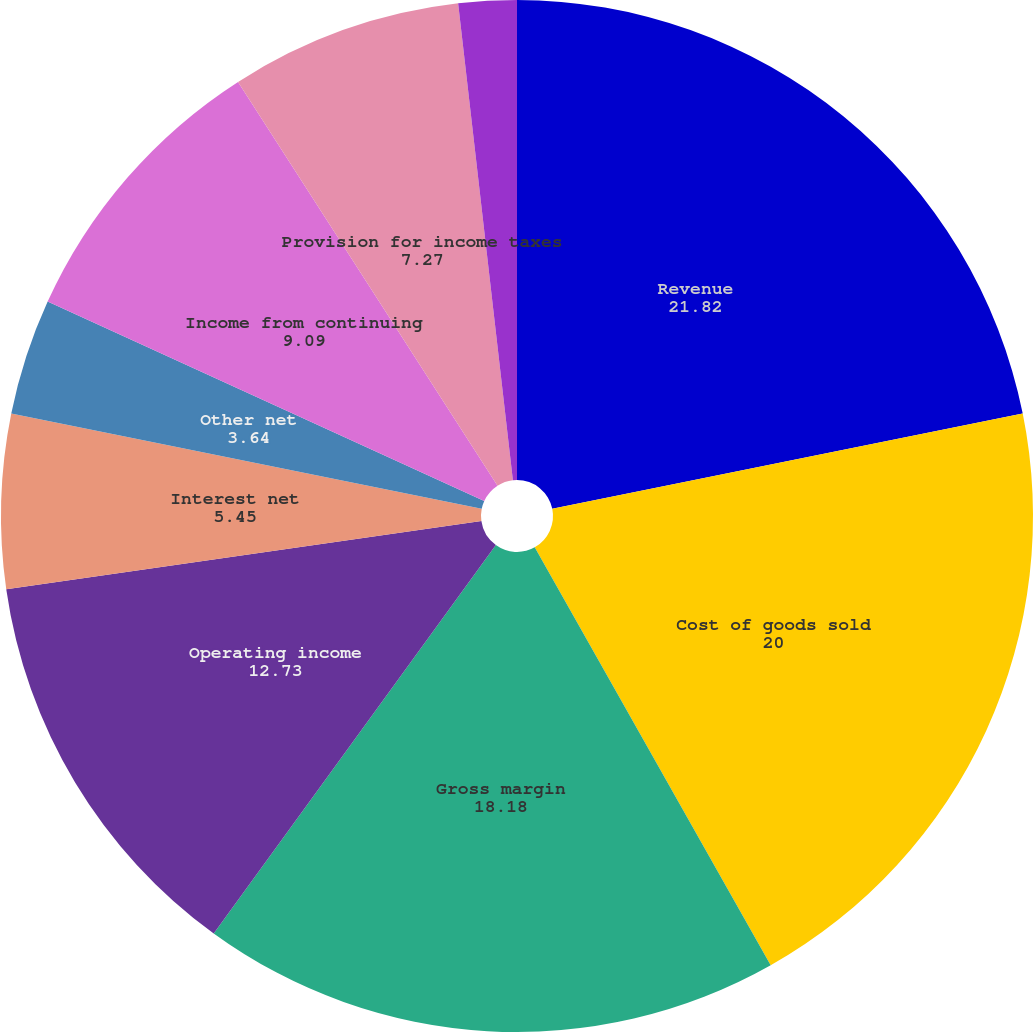<chart> <loc_0><loc_0><loc_500><loc_500><pie_chart><fcel>Revenue<fcel>Cost of goods sold<fcel>Gross margin<fcel>Operating income<fcel>Interest net<fcel>Other net<fcel>Income from continuing<fcel>Provision for income taxes<fcel>Basic earnings per share from<nl><fcel>21.82%<fcel>20.0%<fcel>18.18%<fcel>12.73%<fcel>5.45%<fcel>3.64%<fcel>9.09%<fcel>7.27%<fcel>1.82%<nl></chart> 